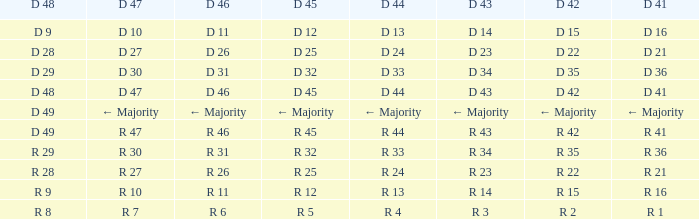Can you give me this table as a dict? {'header': ['D 48', 'D 47', 'D 46', 'D 45', 'D 44', 'D 43', 'D 42', 'D 41'], 'rows': [['D 9', 'D 10', 'D 11', 'D 12', 'D 13', 'D 14', 'D 15', 'D 16'], ['D 28', 'D 27', 'D 26', 'D 25', 'D 24', 'D 23', 'D 22', 'D 21'], ['D 29', 'D 30', 'D 31', 'D 32', 'D 33', 'D 34', 'D 35', 'D 36'], ['D 48', 'D 47', 'D 46', 'D 45', 'D 44', 'D 43', 'D 42', 'D 41'], ['D 49', '← Majority', '← Majority', '← Majority', '← Majority', '← Majority', '← Majority', '← Majority'], ['D 49', 'R 47', 'R 46', 'R 45', 'R 44', 'R 43', 'R 42', 'R 41'], ['R 29', 'R 30', 'R 31', 'R 32', 'R 33', 'R 34', 'R 35', 'R 36'], ['R 28', 'R 27', 'R 26', 'R 25', 'R 24', 'R 23', 'R 22', 'R 21'], ['R 9', 'R 10', 'R 11', 'R 12', 'R 13', 'R 14', 'R 15', 'R 16'], ['R 8', 'R 7', 'R 6', 'R 5', 'R 4', 'R 3', 'R 2', 'R 1']]} Name the D 47 when it has a D 41 of r 36 R 30. 